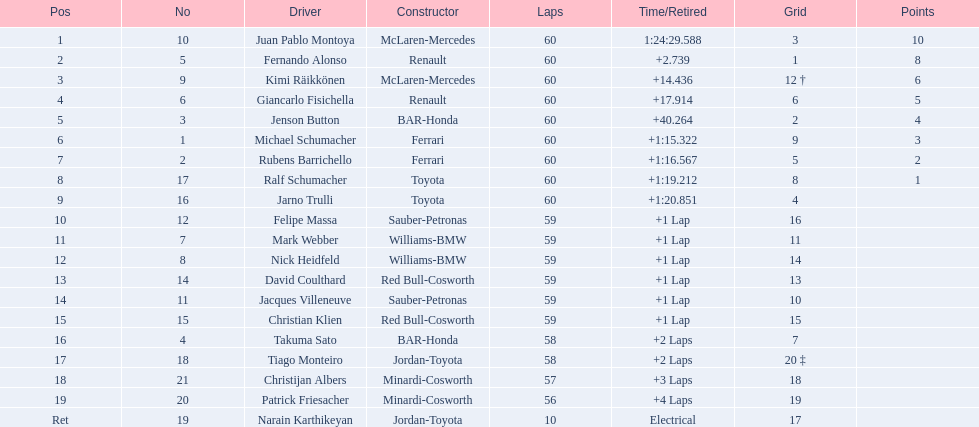Which driver in the top 8, drives a mclaran-mercedes but is not in first place? Kimi Räikkönen. 